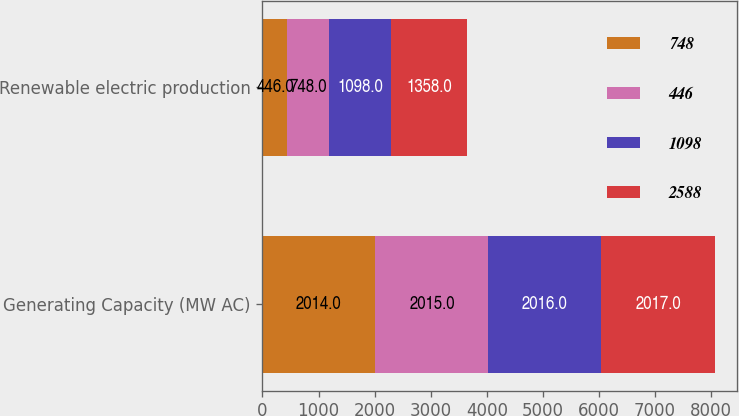Convert chart. <chart><loc_0><loc_0><loc_500><loc_500><stacked_bar_chart><ecel><fcel>Generating Capacity (MW AC)<fcel>Renewable electric production<nl><fcel>748<fcel>2014<fcel>446<nl><fcel>446<fcel>2015<fcel>748<nl><fcel>1098<fcel>2016<fcel>1098<nl><fcel>2588<fcel>2017<fcel>1358<nl></chart> 